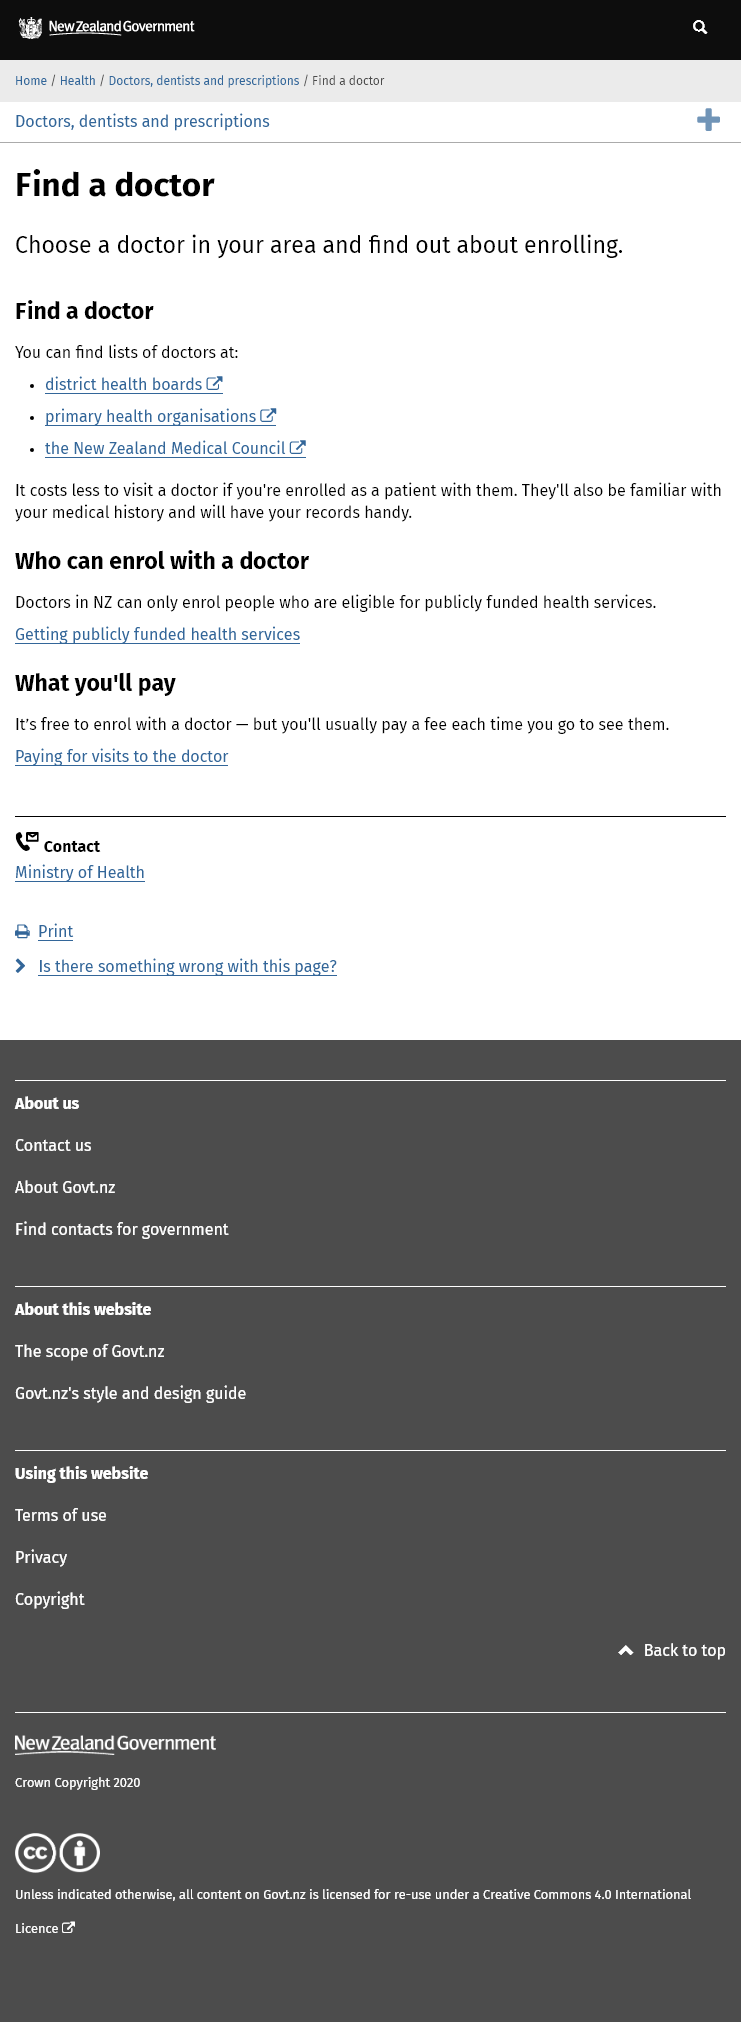Mention a couple of crucial points in this snapshot. It is free to enroll with a doctor and no payment is required for each visit to a doctor, as long as you are enrolled. You can find lists of doctors by consulting the district health boards, primary health organizations, and the New Zealand Medical Council. You can obtain a list of doctors from the District Health Board, primary health organizations, and the New Zealand Medical Council. 